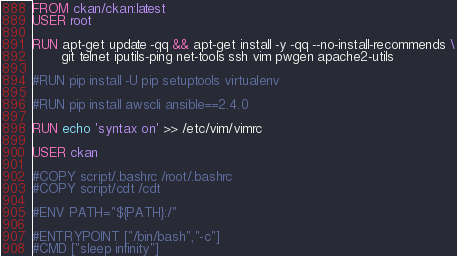<code> <loc_0><loc_0><loc_500><loc_500><_Dockerfile_>FROM ckan/ckan:latest
USER root

RUN apt-get update -qq && apt-get install -y -qq --no-install-recommends \
       git telnet iputils-ping net-tools ssh vim pwgen apache2-utils

#RUN pip install -U pip setuptools virtualenv

#RUN pip install awscli ansible==2.4.0

RUN echo 'syntax on' >> /etc/vim/vimrc

USER ckan

#COPY script/.bashrc /root/.bashrc
#COPY script/cdt /cdt

#ENV PATH="${PATH}:/"

#ENTRYPOINT ["/bin/bash","-c"]
#CMD ["sleep infinity"]
</code> 